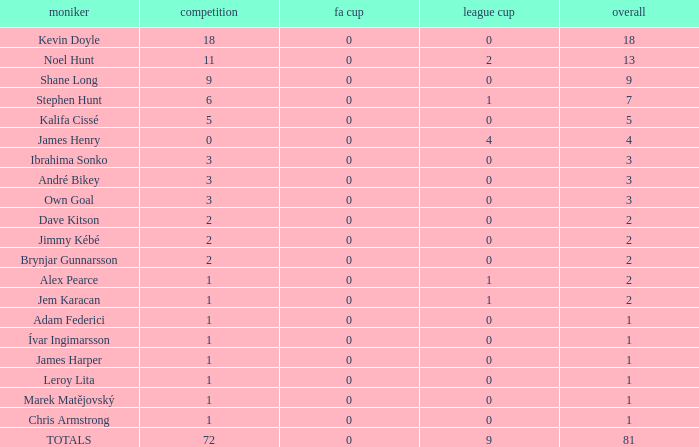What is the total championships of James Henry that has a league cup more than 1? 0.0. 